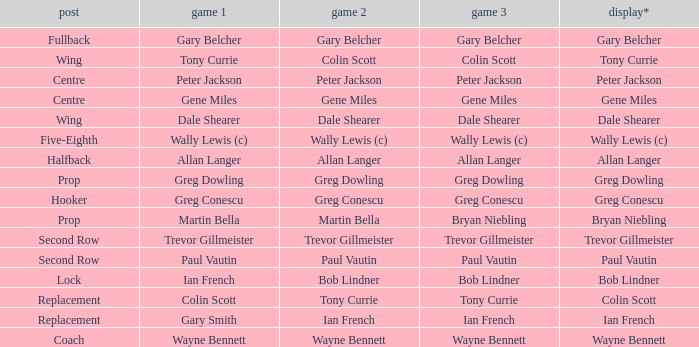What position has colin scott as game 1? Replacement. 